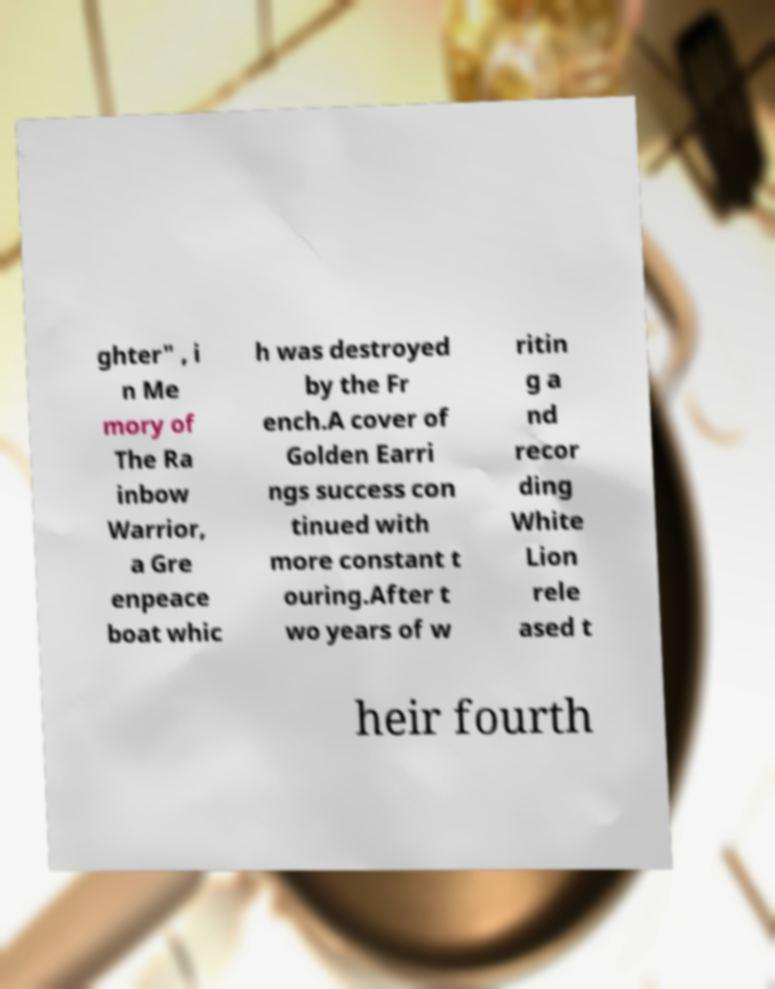Please identify and transcribe the text found in this image. ghter" , i n Me mory of The Ra inbow Warrior, a Gre enpeace boat whic h was destroyed by the Fr ench.A cover of Golden Earri ngs success con tinued with more constant t ouring.After t wo years of w ritin g a nd recor ding White Lion rele ased t heir fourth 